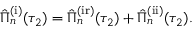Convert formula to latex. <formula><loc_0><loc_0><loc_500><loc_500>\begin{array} { r } { \hat { \Pi } _ { n } ^ { ( i ) } ( \tau _ { 2 } ) = \hat { \Pi } _ { n } ^ { ( i r ) } ( \tau _ { 2 } ) + \hat { \Pi } _ { n } ^ { ( i i ) } ( \tau _ { 2 } ) . } \end{array}</formula> 